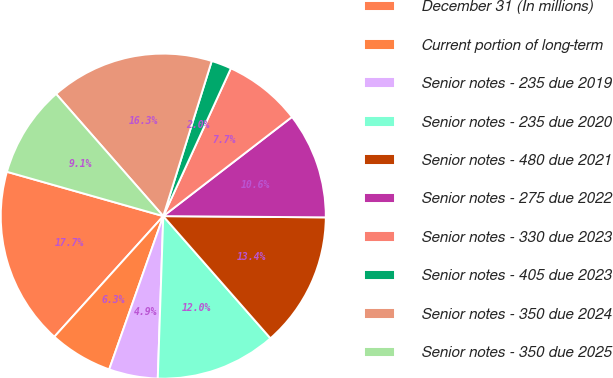Convert chart. <chart><loc_0><loc_0><loc_500><loc_500><pie_chart><fcel>December 31 (In millions)<fcel>Current portion of long-term<fcel>Senior notes - 235 due 2019<fcel>Senior notes - 235 due 2020<fcel>Senior notes - 480 due 2021<fcel>Senior notes - 275 due 2022<fcel>Senior notes - 330 due 2023<fcel>Senior notes - 405 due 2023<fcel>Senior notes - 350 due 2024<fcel>Senior notes - 350 due 2025<nl><fcel>17.71%<fcel>6.29%<fcel>4.86%<fcel>12.0%<fcel>13.42%<fcel>10.57%<fcel>7.72%<fcel>2.01%<fcel>16.28%<fcel>9.14%<nl></chart> 